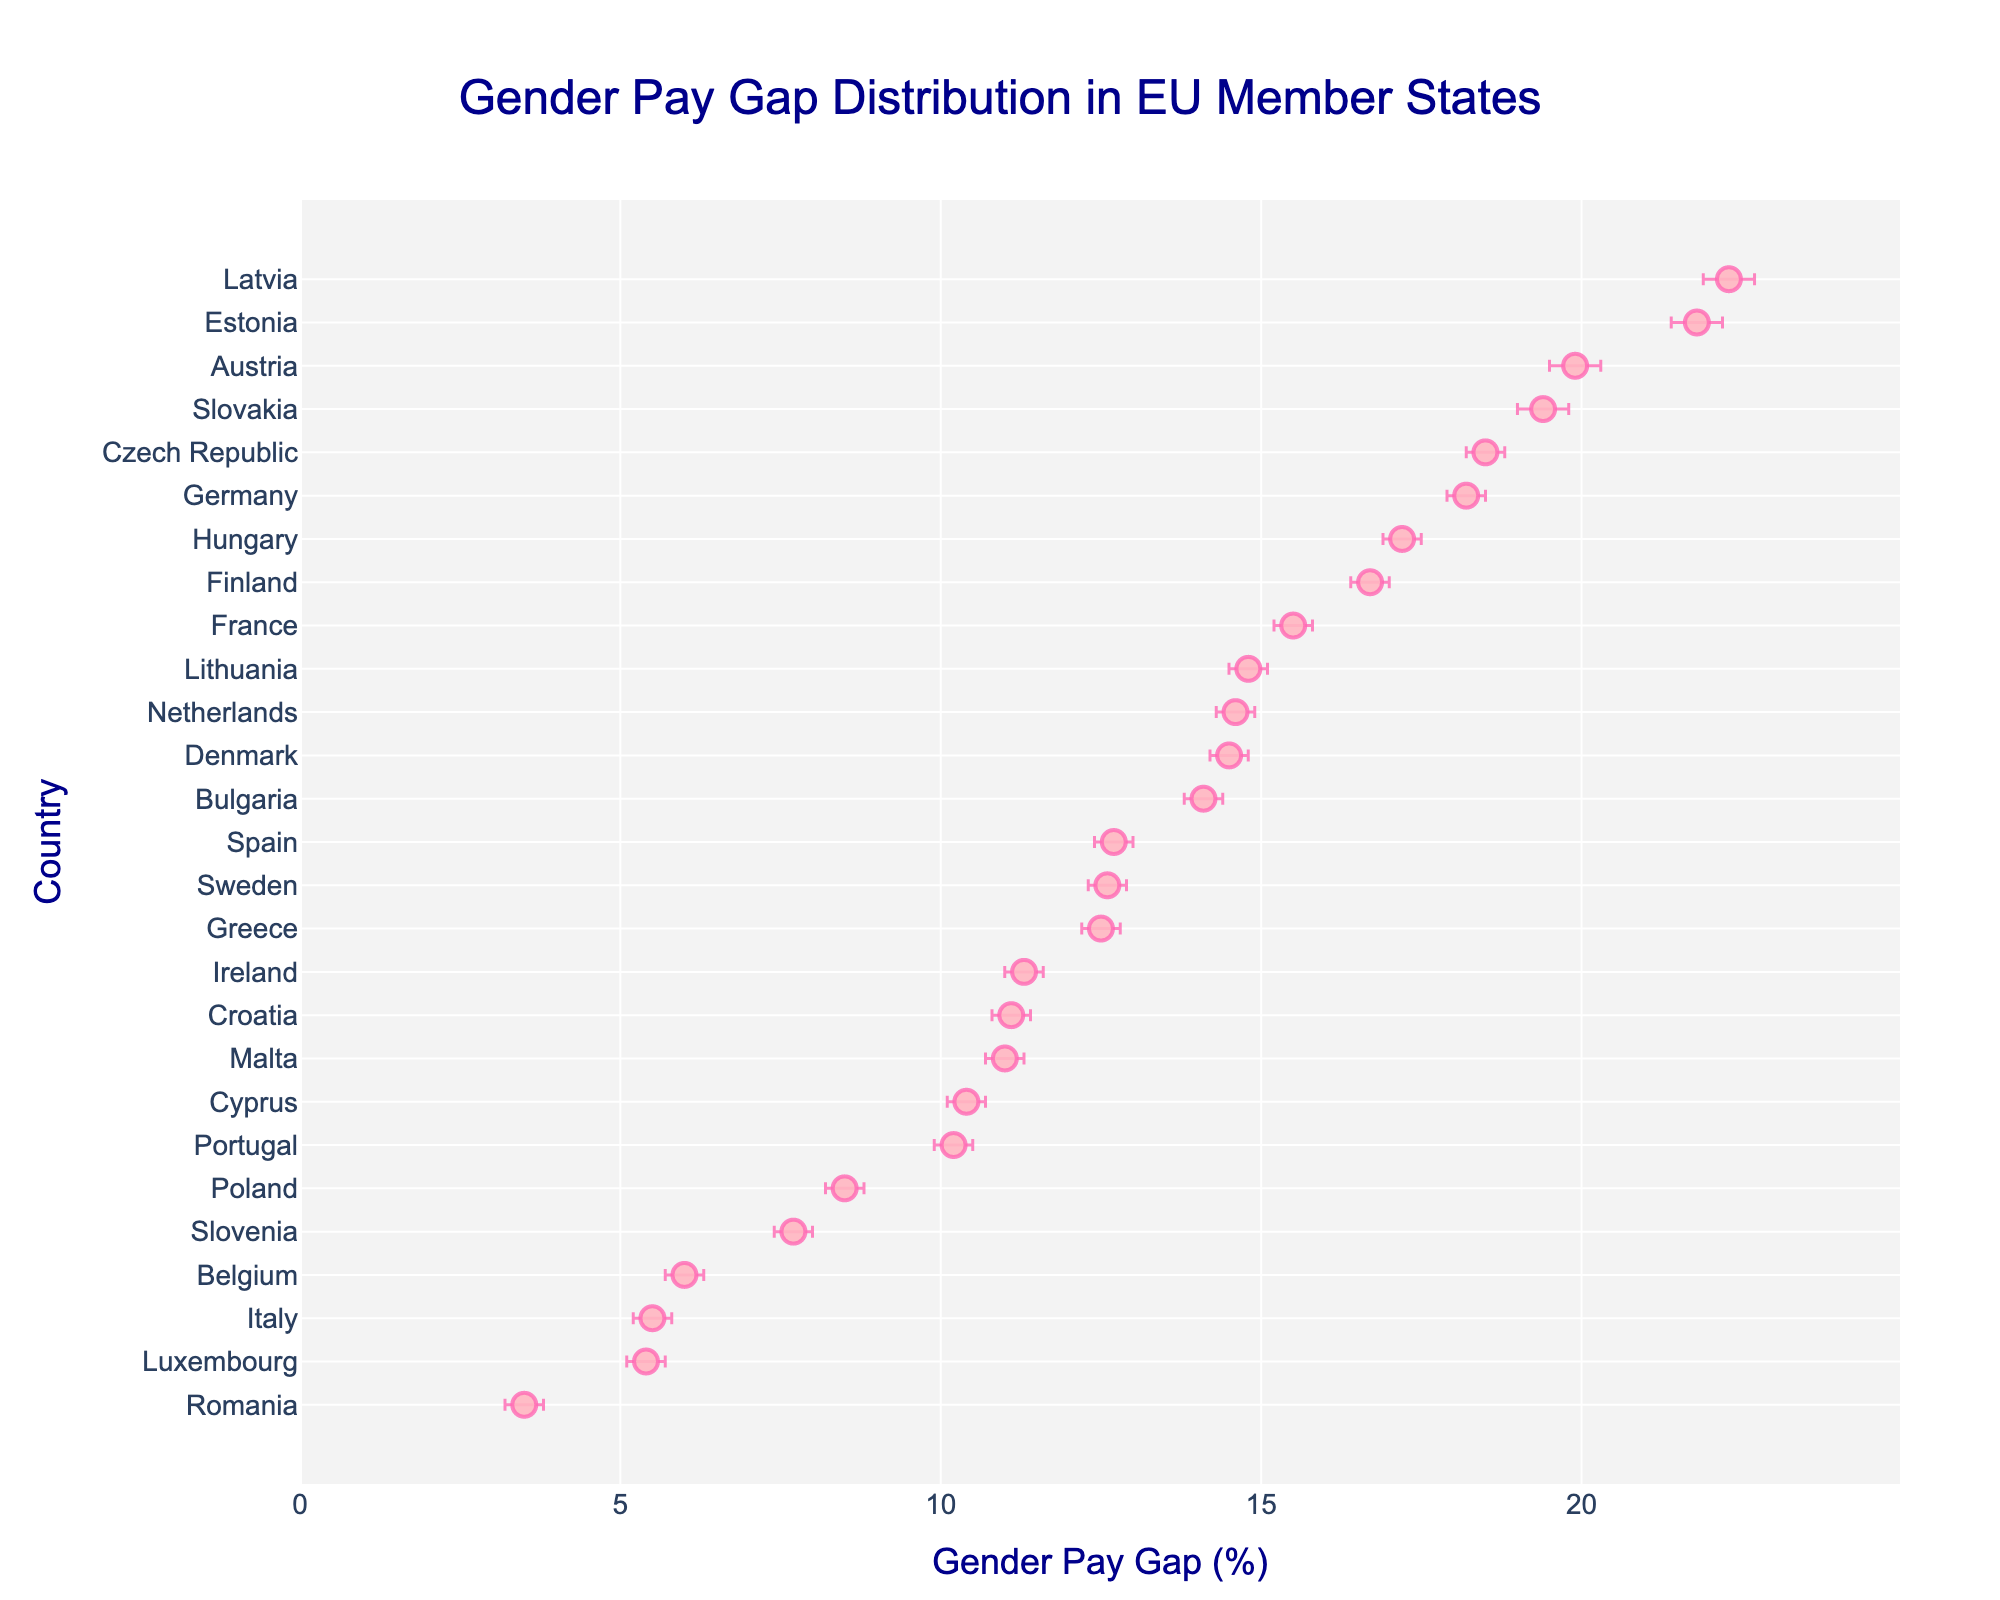What's the title of the figure? The title of the figure is written at the top center of the plot in a larger font. It provides an overview of what the plot represents.
Answer: Gender Pay Gap Distribution in EU Member States Which country has the highest gender pay gap? To determine this, look for the country with the highest dot position along the x-axis (Gender Pay Gap).
Answer: Estonia Which countries have a gender pay gap lower than 10%? Identify all countries with their dots positioned to the left of the 10% mark on the x-axis.
Answer: Belgium, Italy, Luxembourg, Poland, Romania, Slovenia What is the range of the gender pay gap for Austria? The range can be calculated by subtracting the lower confidence interval (19.5) from the upper confidence interval (20.3) for Austria.
Answer: 0.8% How does the gender pay gap in Germany compare to that in the Czech Republic? Compare the x-axis positions of Germany and the Czech Republic. Germany has a gender pay gap of 18.2%, and the Czech Republic has 18.5%, so the Czech Republic has a slightly higher gender pay gap.
Answer: Germany is lower Which country has the smallest gender pay gap and what is its value? Look for the country with the lowest dot position on the x-axis and note its value.
Answer: Romania, 3.5% How do the confidence intervals for Belgium and Italy compare? Compare the lengths of the error bars for Belgium and Italy. Belgium's error bars range from 5.7 to 6.3, while Italy's range from 5.2 to 5.8. This means Belgium's interval is wider.
Answer: Belgium has a wider interval What is the median gender pay gap among the listed countries? To find the median value, list all gender pay gap percentages in ascending order and find the middle value. After sorting, the median of 27 countries' data points is the 14th value.
Answer: 12.7% Which country shows the highest uncertainty in its gender pay gap measure? Identify the country with the widest range between the lower and upper confidence intervals. Calculate the range for each and compare them.
Answer: Latvia Which country has a gender pay gap closest to the EU average (mean)? First, calculate the average of all gender pay gaps, then identify the country with the gender pay gap value nearest to this average by comparing the differences. The mean can be calculated as follows: (sum of all gender pay gaps) / (number of countries).
Answer: Finland 